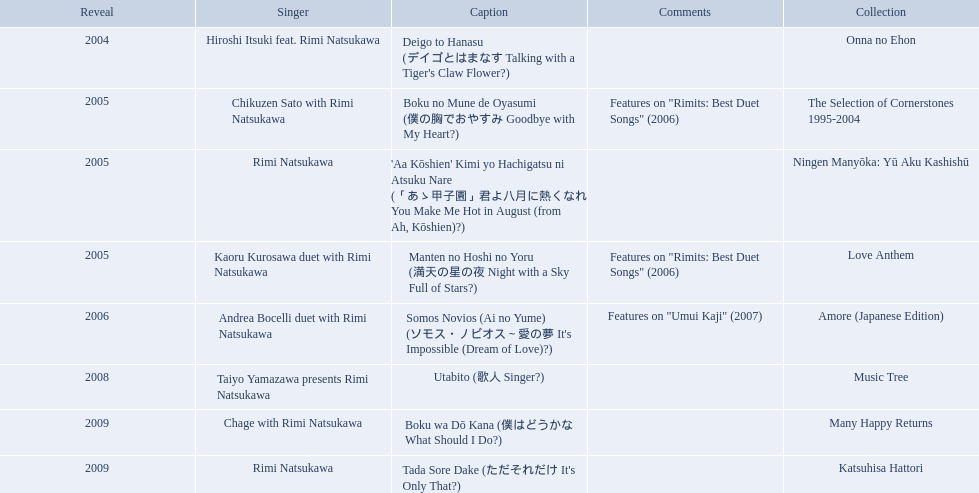What are the names of each album by rimi natsukawa? Onna no Ehon, The Selection of Cornerstones 1995-2004, Ningen Manyōka: Yū Aku Kashishū, Love Anthem, Amore (Japanese Edition), Music Tree, Many Happy Returns, Katsuhisa Hattori. And when were the albums released? 2004, 2005, 2005, 2005, 2006, 2008, 2009, 2009. Was onna no ehon or music tree released most recently? Music Tree. When was onna no ehon released? 2004. When was the selection of cornerstones 1995-2004 released? 2005. What was released in 2008? Music Tree. Which title of the rimi natsukawa discography was released in the 2004? Deigo to Hanasu (デイゴとはまなす Talking with a Tiger's Claw Flower?). Which title has notes that features on/rimits. best duet songs\2006 Manten no Hoshi no Yoru (満天の星の夜 Night with a Sky Full of Stars?). Which title share the same notes as night with a sky full of stars? Boku no Mune de Oyasumi (僕の胸でおやすみ Goodbye with My Heart?). 